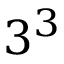<formula> <loc_0><loc_0><loc_500><loc_500>3 ^ { 3 }</formula> 